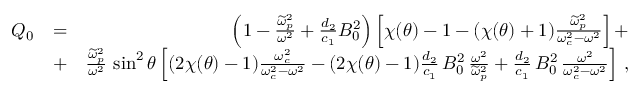<formula> <loc_0><loc_0><loc_500><loc_500>\begin{array} { r l r } { Q _ { 0 } } & { = } & { \left ( 1 - \frac { \widetilde { \omega } _ { p } ^ { 2 } } { \omega ^ { 2 } } + \frac { d _ { 2 } } { c _ { 1 } } B _ { 0 } ^ { 2 } \right ) \left [ \chi ( \theta ) - 1 - ( \chi ( \theta ) + 1 ) \frac { \widetilde { \omega } _ { p } ^ { 2 } } { \omega _ { c } ^ { 2 } - \omega ^ { 2 } } \right ] + } \\ & { + } & { \frac { \widetilde { \omega } _ { p } ^ { 2 } } { \omega ^ { 2 } } \, \sin ^ { 2 } \theta \left [ ( 2 \chi ( \theta ) - 1 ) \frac { \omega _ { c } ^ { 2 } } { \omega _ { c } ^ { 2 } - \omega ^ { 2 } } - ( 2 \chi ( \theta ) - 1 ) \frac { d _ { 2 } } { c _ { 1 } } \, B _ { 0 } ^ { 2 } \, \frac { \omega ^ { 2 } } { \widetilde { \omega } _ { p } ^ { 2 } } + \frac { d _ { 2 } } { c _ { 1 } } \, B _ { 0 } ^ { 2 } \, \frac { \omega ^ { 2 } } { \omega _ { c } ^ { 2 } - \omega ^ { 2 } } \right ] \, , } \end{array}</formula> 